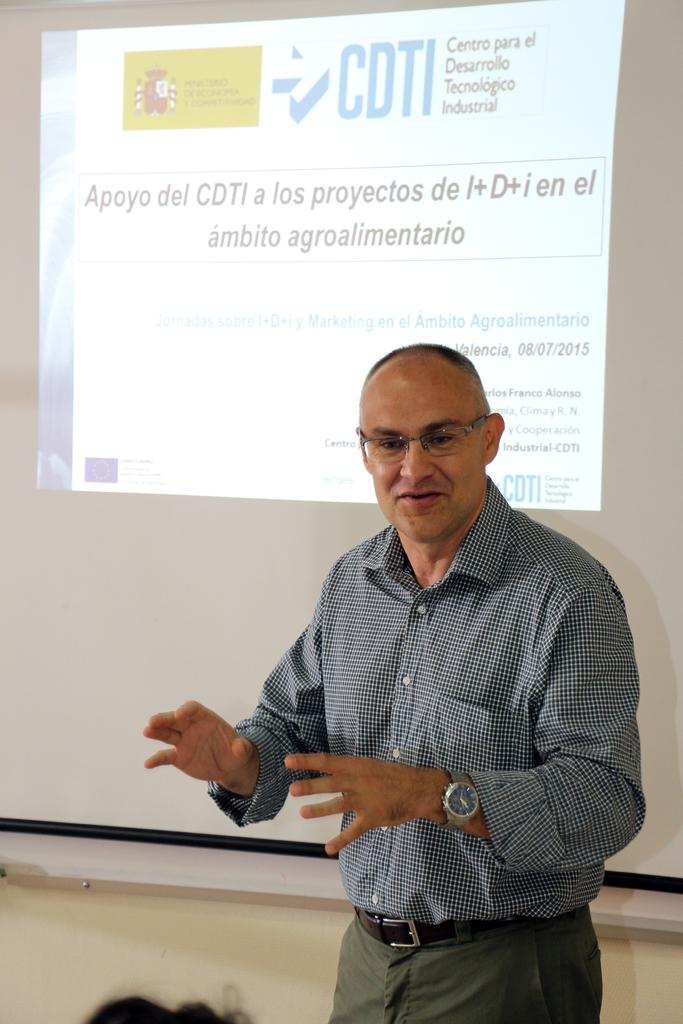Who is the main subject in the image? There is a man in the middle of the image. What is located on the left side of the image? There is a person's hair on the left side of the image. What can be seen in the background of the image? There is a screen with pictures and text in the background of the image. Can you tell me how many kittens are making a request in the image? There are no kittens or requests present in the image. 